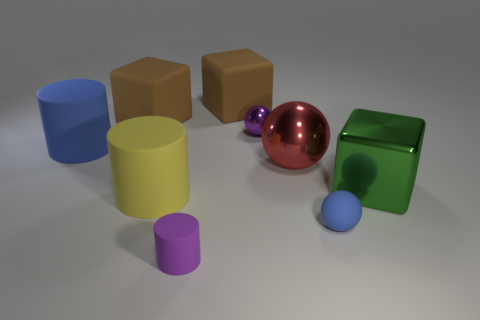Can you describe the arrangement of the different objects in the image? In the image, you can see a collection of geometric shapes scattered on a flat surface. On the left, there's a blue cylinder lying horizontally with a smaller purple cylinder in front of it. To the right, a yellow cube is adjacent to another cube with a similar size but in tan color. In the center, a shiny red sphere catches the eye, positioned in front of the blue cylinder. At the far right, a green cube stands with a smaller blue sphere in front. The arrangement has a slight disarray, giving a casual, random feel to the composition. 